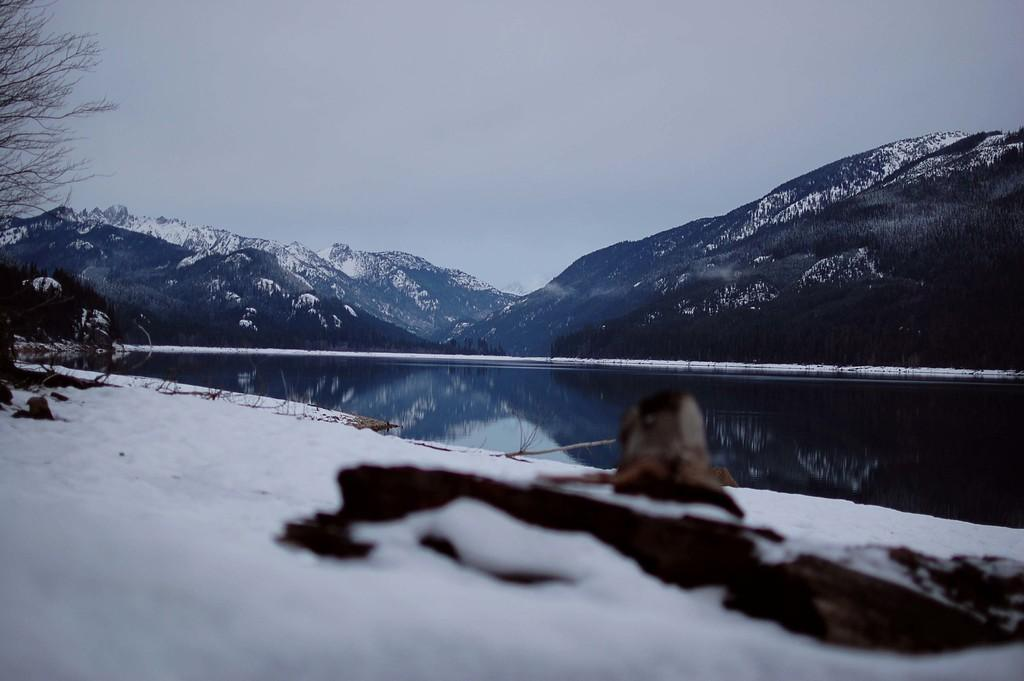What type of weather is depicted in the image? There is snow in the image, indicating cold weather. What natural feature can be seen in the image? There are mountains in the image. What is the water element in the image? There is water in the image. What can be seen on the left side of the image? There are branches on the left side of the image. What is visible in the background of the image? The sky is visible in the background of the image. Can you see someone wearing a sweater and carrying a basket in the image? There is no person wearing a sweater or carrying a basket present in the image. 